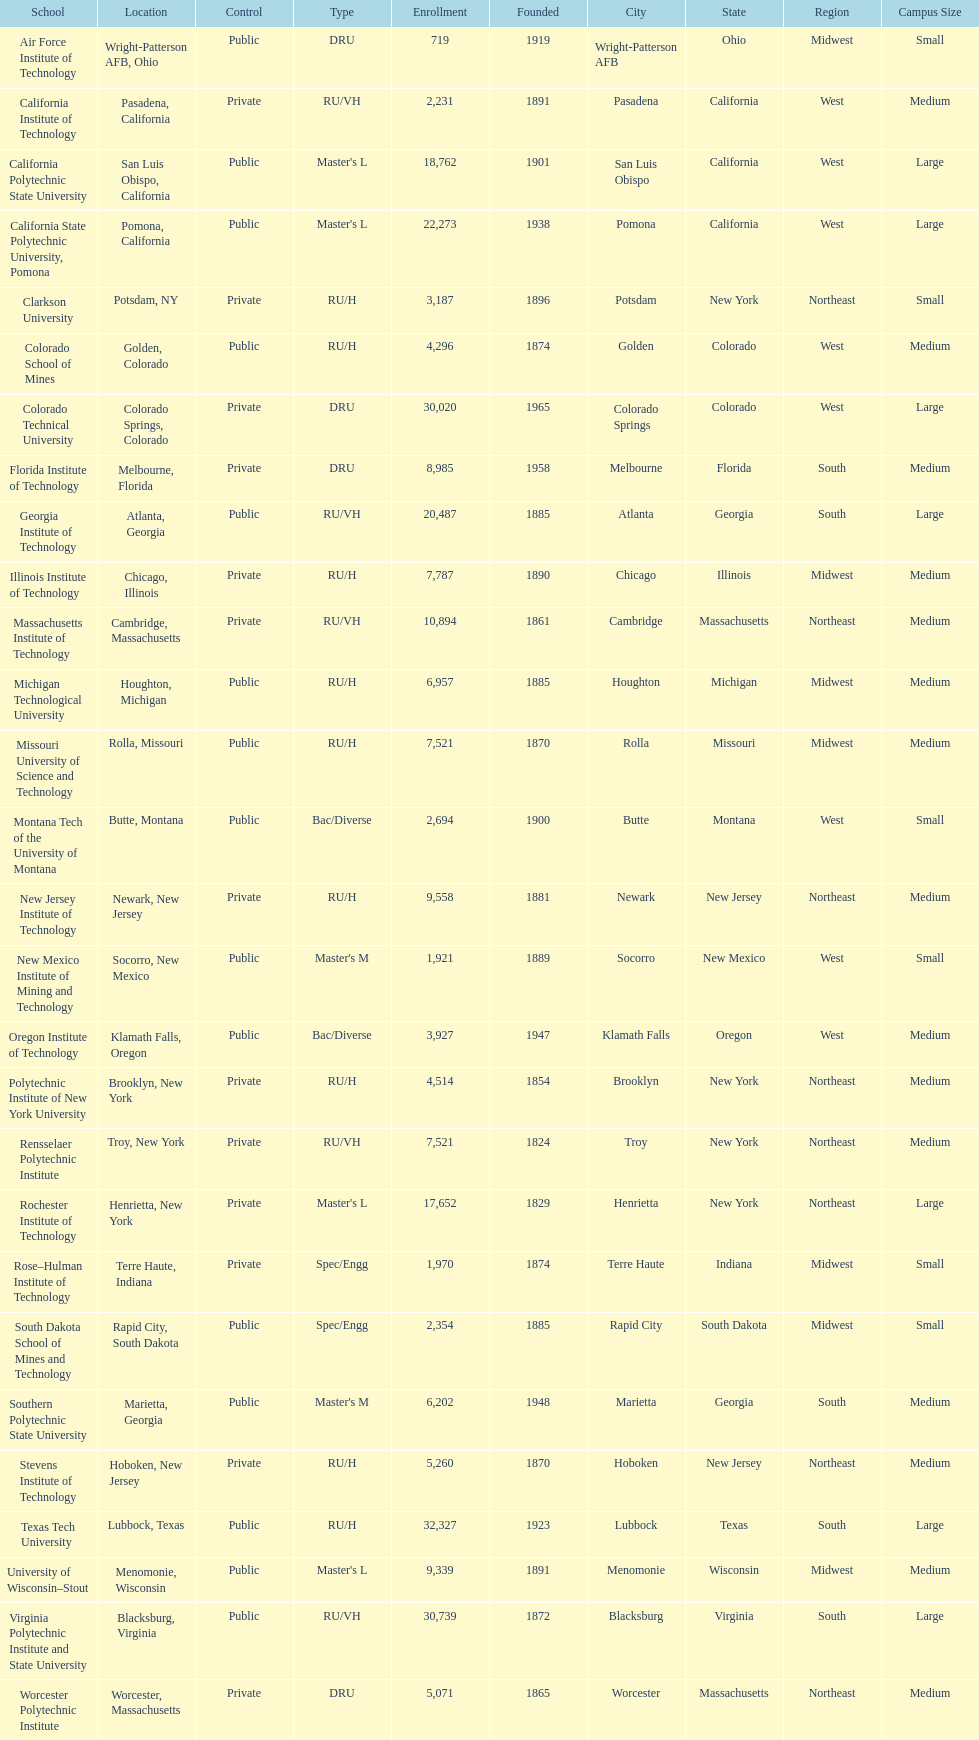What is the number of us technological schools in the state of california? 3. 